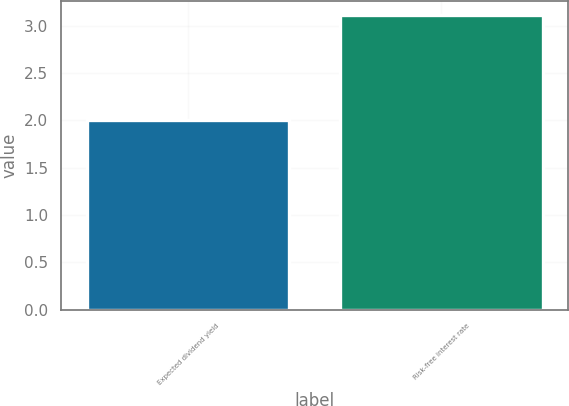Convert chart to OTSL. <chart><loc_0><loc_0><loc_500><loc_500><bar_chart><fcel>Expected dividend yield<fcel>Risk-free interest rate<nl><fcel>2<fcel>3.11<nl></chart> 